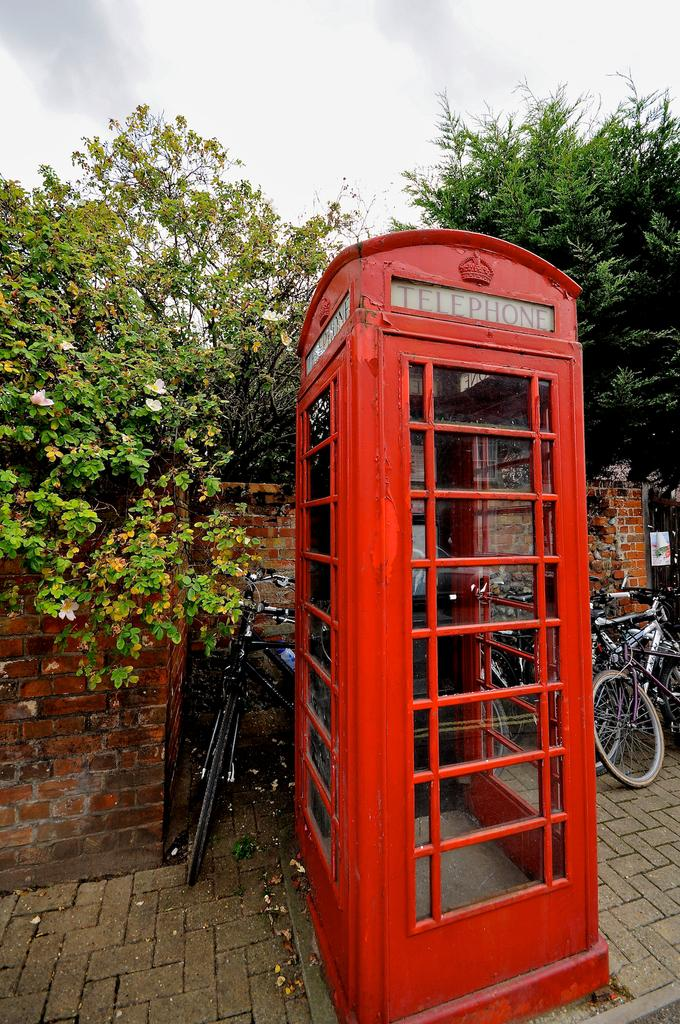What type of structure is present in the image? There is a telephone booth in the image. What mode of transportation can be seen in the image? There are bicycles in the image. What type of vegetation is visible in the image? There are trees in the image. What architectural feature is present in the image? There is a wall in the image. What can be seen in the background of the image? The sky is visible in the background of the image. Can you tell me how many faces can be seen in the image? There are no faces present in the image. What type of war is depicted in the image? There is no war depicted in the image; it features a telephone booth, bicycles, trees, a wall, and the sky. 